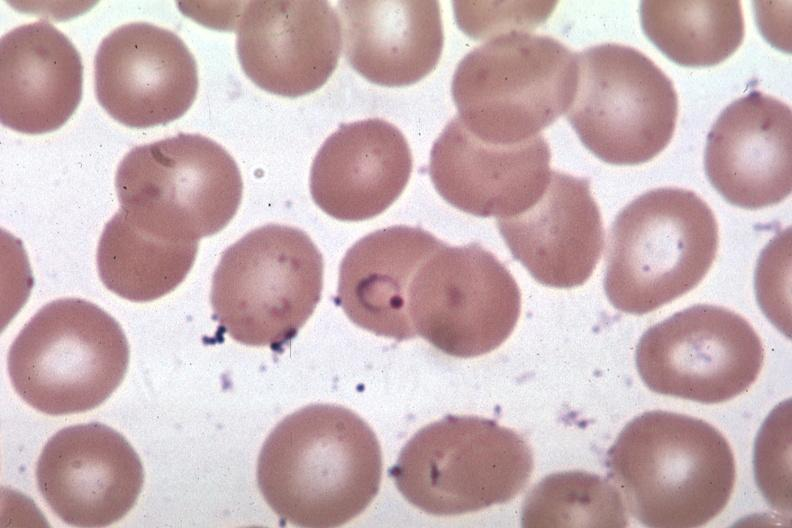s metastatic carcinoma colon present?
Answer the question using a single word or phrase. No 